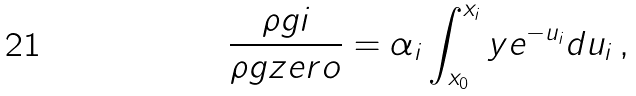<formula> <loc_0><loc_0><loc_500><loc_500>\frac { \rho g i } { \rho g z e r o } = \alpha _ { i } \int _ { x _ { 0 } } ^ { x _ { i } } y e ^ { - u _ { i } } d u _ { i } \, ,</formula> 